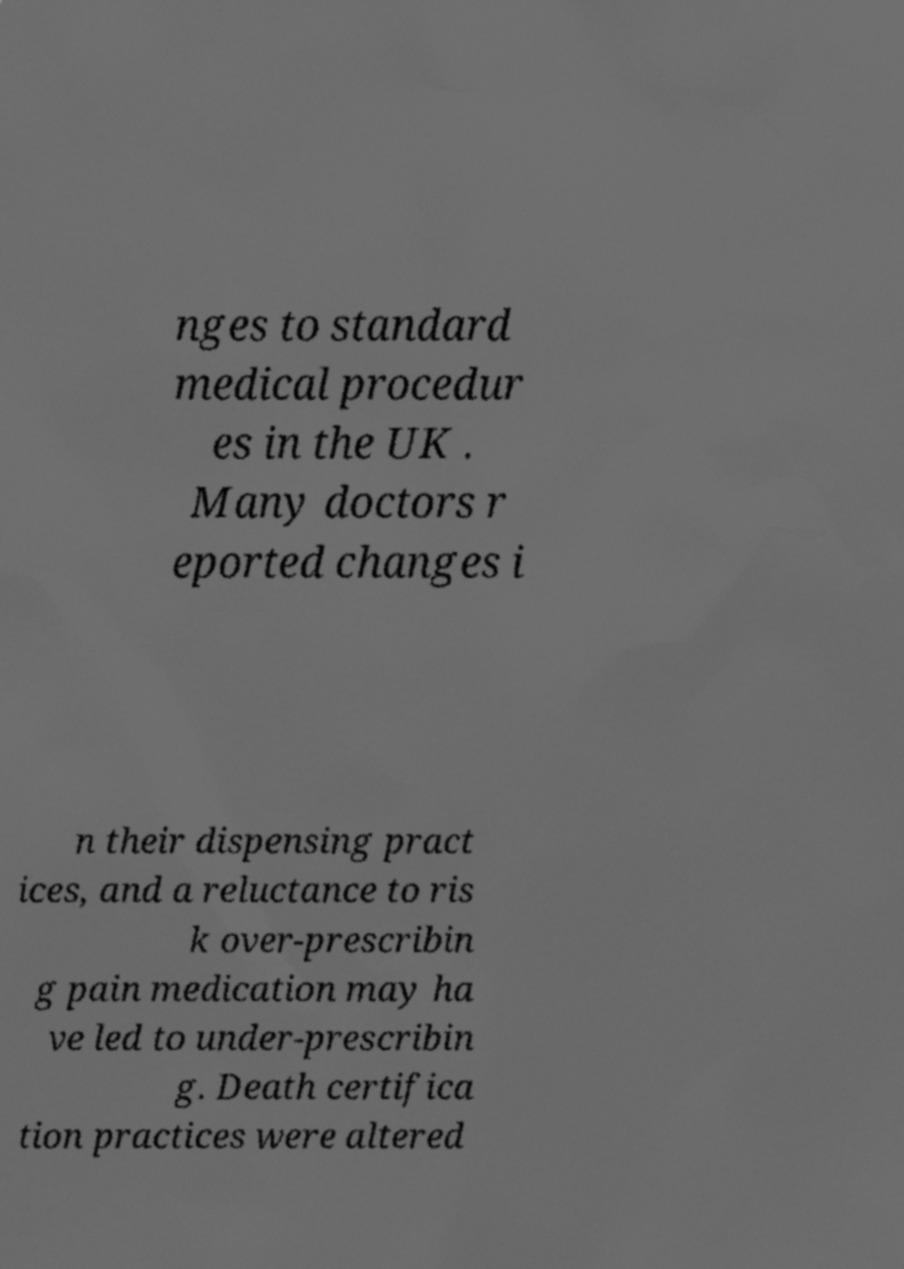I need the written content from this picture converted into text. Can you do that? nges to standard medical procedur es in the UK . Many doctors r eported changes i n their dispensing pract ices, and a reluctance to ris k over-prescribin g pain medication may ha ve led to under-prescribin g. Death certifica tion practices were altered 